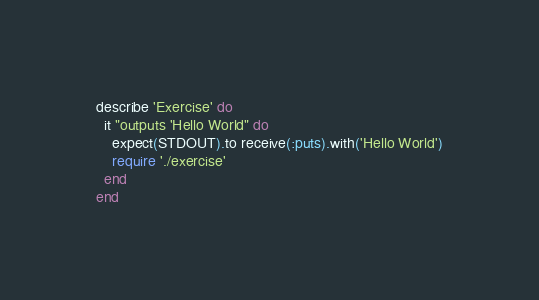<code> <loc_0><loc_0><loc_500><loc_500><_Ruby_>describe 'Exercise' do
  it "outputs 'Hello World" do
    expect(STDOUT).to receive(:puts).with('Hello World')
    require './exercise'
  end
end
</code> 